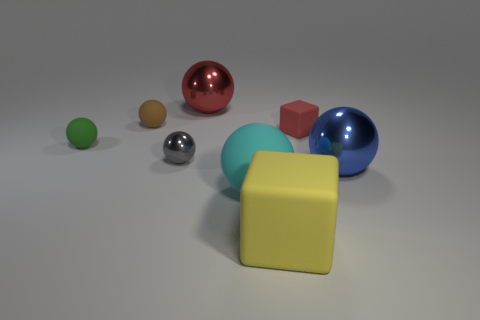What size is the blue sphere?
Offer a very short reply. Large. What number of shiny objects are red spheres or big balls?
Your answer should be very brief. 2. Are there fewer gray things than objects?
Your answer should be compact. Yes. What number of other objects are the same material as the large yellow cube?
Offer a terse response. 4. There is a red object that is the same shape as the tiny brown rubber object; what size is it?
Offer a very short reply. Large. Is the red object that is on the left side of the big cyan ball made of the same material as the red thing in front of the large red metal thing?
Your answer should be compact. No. Is the number of big blue things that are to the left of the big cyan matte ball less than the number of yellow matte cubes?
Your answer should be very brief. Yes. There is another large rubber object that is the same shape as the brown object; what color is it?
Your answer should be compact. Cyan. Does the rubber block in front of the gray object have the same size as the blue metal object?
Keep it short and to the point. Yes. How big is the red thing right of the large shiny thing that is behind the large blue metallic ball?
Offer a very short reply. Small. 